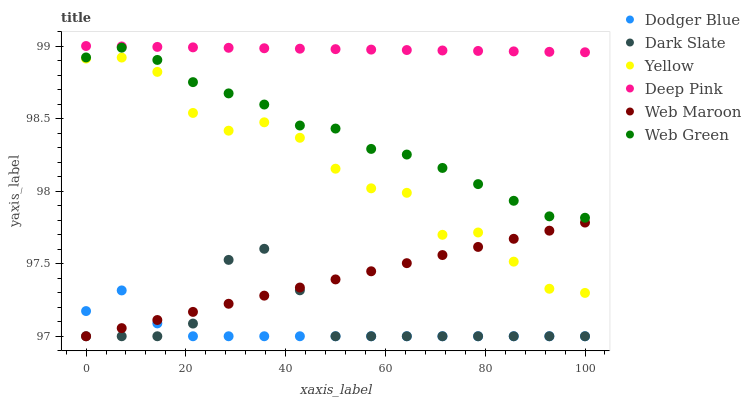Does Dodger Blue have the minimum area under the curve?
Answer yes or no. Yes. Does Deep Pink have the maximum area under the curve?
Answer yes or no. Yes. Does Web Maroon have the minimum area under the curve?
Answer yes or no. No. Does Web Maroon have the maximum area under the curve?
Answer yes or no. No. Is Web Maroon the smoothest?
Answer yes or no. Yes. Is Yellow the roughest?
Answer yes or no. Yes. Is Web Green the smoothest?
Answer yes or no. No. Is Web Green the roughest?
Answer yes or no. No. Does Web Maroon have the lowest value?
Answer yes or no. Yes. Does Web Green have the lowest value?
Answer yes or no. No. Does Deep Pink have the highest value?
Answer yes or no. Yes. Does Web Maroon have the highest value?
Answer yes or no. No. Is Dodger Blue less than Deep Pink?
Answer yes or no. Yes. Is Deep Pink greater than Web Green?
Answer yes or no. Yes. Does Web Maroon intersect Dodger Blue?
Answer yes or no. Yes. Is Web Maroon less than Dodger Blue?
Answer yes or no. No. Is Web Maroon greater than Dodger Blue?
Answer yes or no. No. Does Dodger Blue intersect Deep Pink?
Answer yes or no. No. 